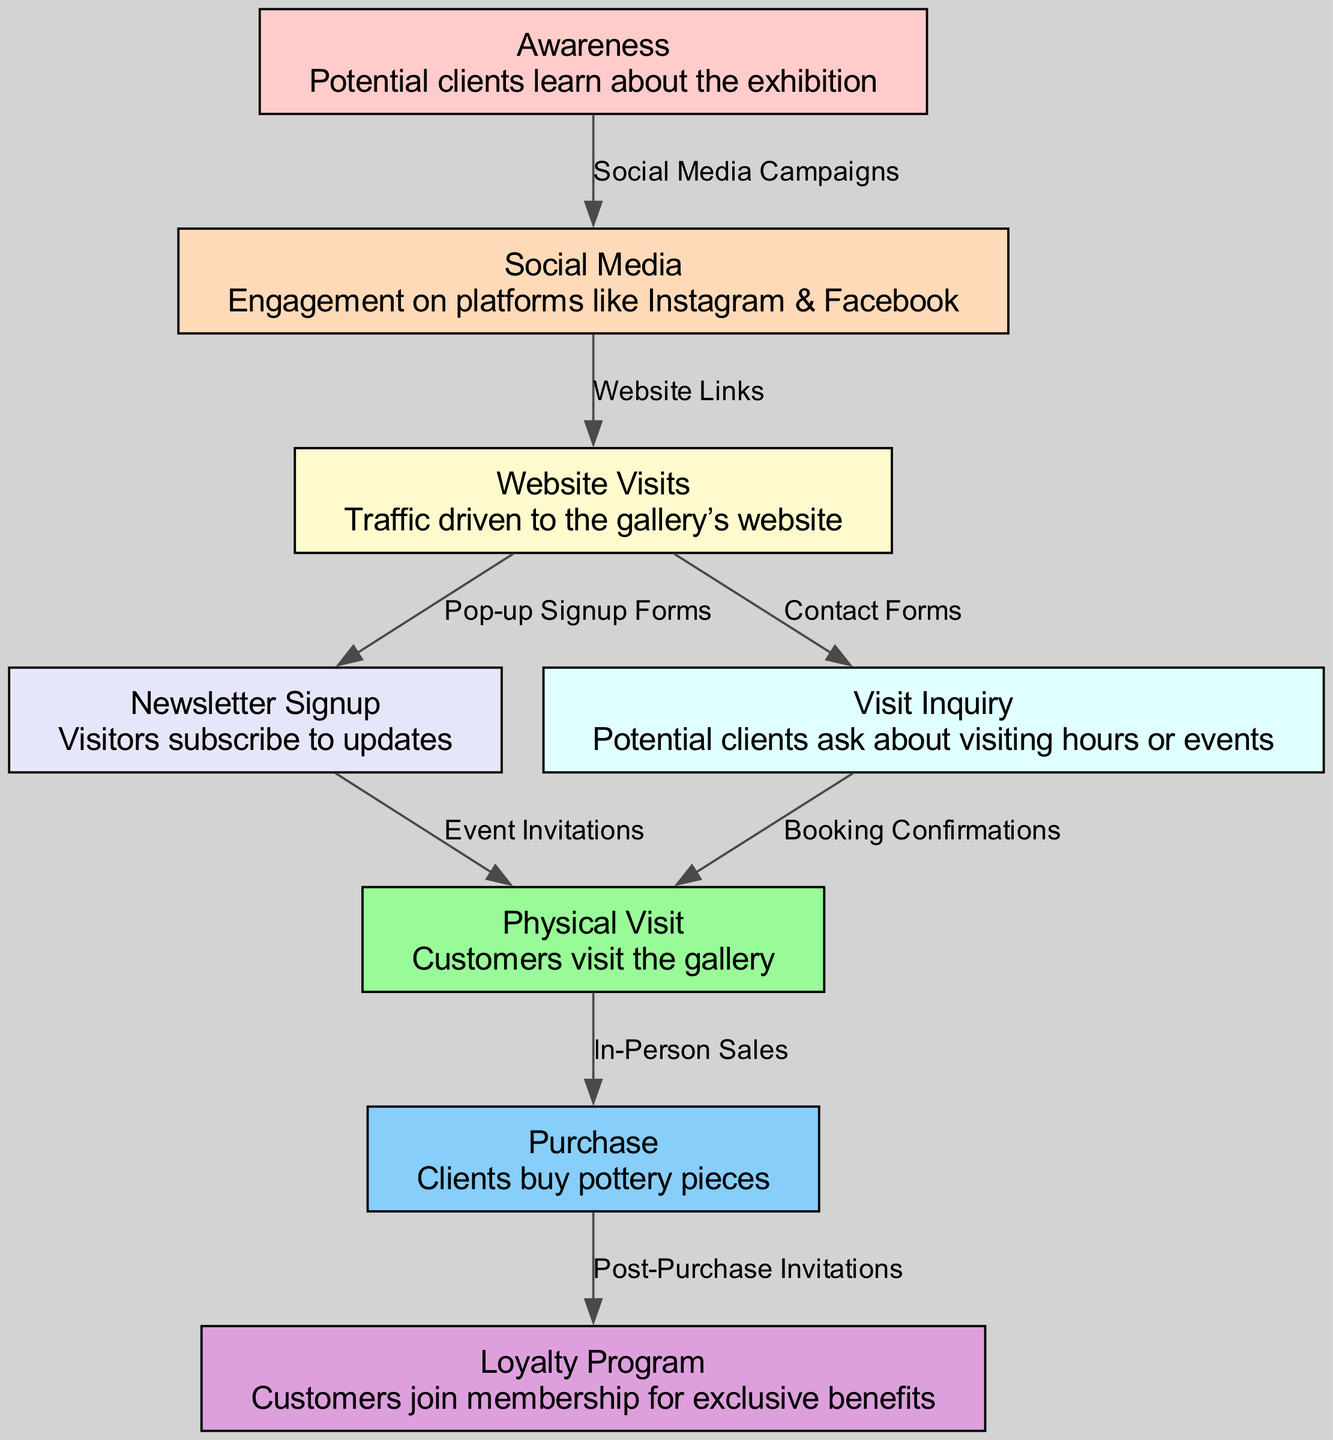What is the first stage in the engagement funnel? The diagram shows "Awareness" as the first stage of the funnel, where potential clients learn about the exhibition. This is the starting point of the customer engagement process.
Answer: Awareness How many nodes are present in the diagram? By counting the unique entries in the "nodes" section of the data, we can see there are eight distinct nodes representing different stages.
Answer: Eight What type of engagement occurs after 'Social Media'? The diagram indicates that the engagement occurring after "Social Media" is "Website Visits". This flow is directed from the "Social Media" node leading into "Website Visits".
Answer: Website Visits What labels connect 'Website Visits' to other nodes? The two connections from "Website Visits" are labeled "Pop-up Signup Forms" leading to "Newsletter Signup" and "Contact Forms" leading to "Visit Inquiry". Both edges are illustrated coming out from the "Website Visits" node.
Answer: Pop-up Signup Forms, Contact Forms Which node directly leads to the 'Loyalty Program'? The flow from "Purchase" directly leads to "Loyalty Program", shown as a post-purchase engagement to encourage customer loyalty among buyers. This relationship indicates what happens after a purchase is made.
Answer: Purchase What is the overall direction of the engagement funnel? The diagram illustrates a downward flow from "Awareness" at the top to "Loyalty Program" at the bottom, showing the progression through the customer engagement stages in a funnel format.
Answer: Downward Explain the relationship between 'Visit Inquiry' and 'Physical Visit'. The flow indicates that "Visit Inquiry" leads to "Physical Visit" through "Booking Confirmations". This means that inquiries about visits directly facilitate physical attendance at the gallery, creating a direct interaction line.
Answer: Booking Confirmations What happens after a customer makes a 'Purchase'? After making a "Purchase", clients receive "Post-Purchase Invitations" that lead them to join the "Loyalty Program". This step emphasizes following up with clients after a sale to build loyalty.
Answer: Post-Purchase Invitations 